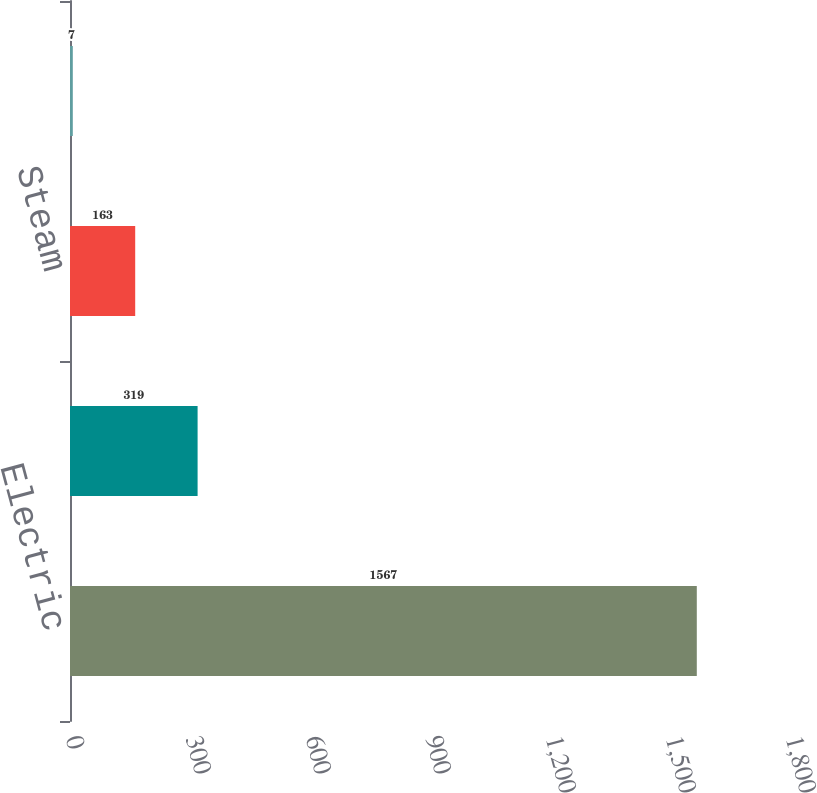<chart> <loc_0><loc_0><loc_500><loc_500><bar_chart><fcel>Electric<fcel>Gas<fcel>Steam<fcel>Competitive energy businesses<nl><fcel>1567<fcel>319<fcel>163<fcel>7<nl></chart> 